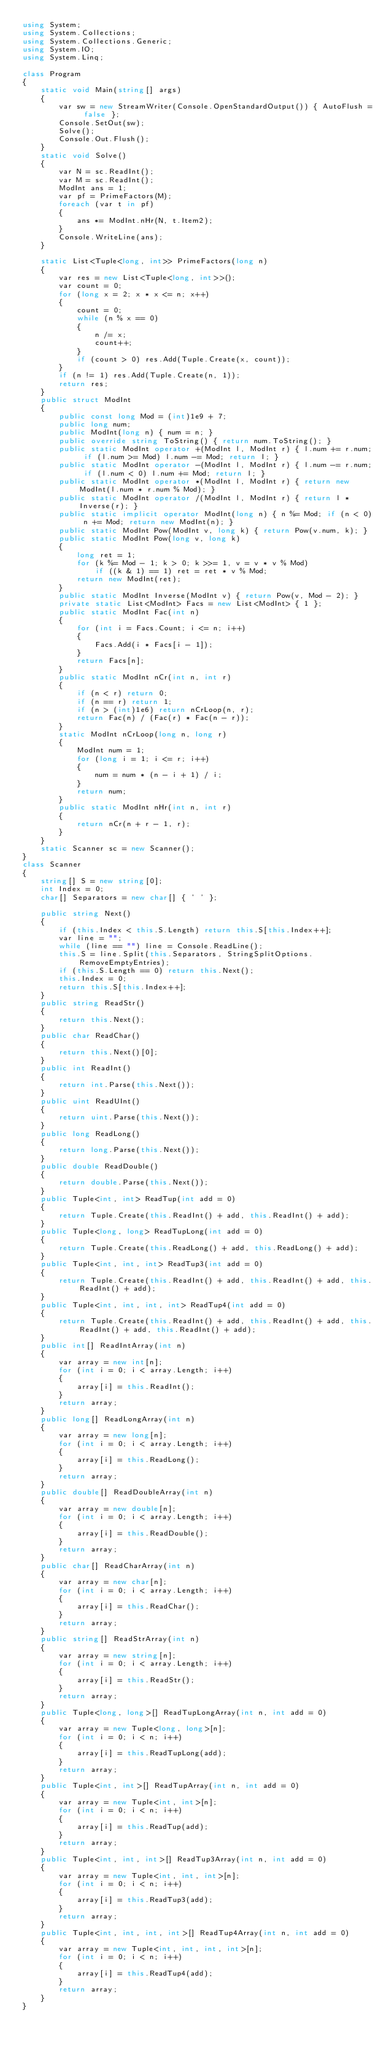<code> <loc_0><loc_0><loc_500><loc_500><_C#_>using System;
using System.Collections;
using System.Collections.Generic;
using System.IO;
using System.Linq;

class Program
{
    static void Main(string[] args)
    {
        var sw = new StreamWriter(Console.OpenStandardOutput()) { AutoFlush = false };
        Console.SetOut(sw);
        Solve();
        Console.Out.Flush();
    }
    static void Solve()
    {
        var N = sc.ReadInt();
        var M = sc.ReadInt();
        ModInt ans = 1;
        var pf = PrimeFactors(M);
        foreach (var t in pf)
        {
            ans *= ModInt.nHr(N, t.Item2);
        }
        Console.WriteLine(ans);
    }

    static List<Tuple<long, int>> PrimeFactors(long n)
    {
        var res = new List<Tuple<long, int>>();
        var count = 0;
        for (long x = 2; x * x <= n; x++)
        {
            count = 0;
            while (n % x == 0)
            {
                n /= x;
                count++;
            }
            if (count > 0) res.Add(Tuple.Create(x, count));
        }
        if (n != 1) res.Add(Tuple.Create(n, 1));
        return res;
    }
    public struct ModInt
    {
        public const long Mod = (int)1e9 + 7;
        public long num;
        public ModInt(long n) { num = n; }
        public override string ToString() { return num.ToString(); }
        public static ModInt operator +(ModInt l, ModInt r) { l.num += r.num; if (l.num >= Mod) l.num -= Mod; return l; }
        public static ModInt operator -(ModInt l, ModInt r) { l.num -= r.num; if (l.num < 0) l.num += Mod; return l; }
        public static ModInt operator *(ModInt l, ModInt r) { return new ModInt(l.num * r.num % Mod); }
        public static ModInt operator /(ModInt l, ModInt r) { return l * Inverse(r); }
        public static implicit operator ModInt(long n) { n %= Mod; if (n < 0) n += Mod; return new ModInt(n); }
        public static ModInt Pow(ModInt v, long k) { return Pow(v.num, k); }
        public static ModInt Pow(long v, long k)
        {
            long ret = 1;
            for (k %= Mod - 1; k > 0; k >>= 1, v = v * v % Mod)
                if ((k & 1) == 1) ret = ret * v % Mod;
            return new ModInt(ret);
        }
        public static ModInt Inverse(ModInt v) { return Pow(v, Mod - 2); }
        private static List<ModInt> Facs = new List<ModInt> { 1 };
        public static ModInt Fac(int n)
        {
            for (int i = Facs.Count; i <= n; i++)
            {
                Facs.Add(i * Facs[i - 1]);
            }
            return Facs[n];
        }
        public static ModInt nCr(int n, int r)
        {
            if (n < r) return 0;
            if (n == r) return 1;
            if (n > (int)1e6) return nCrLoop(n, r);
            return Fac(n) / (Fac(r) * Fac(n - r));
        }
        static ModInt nCrLoop(long n, long r)
        {
            ModInt num = 1;
            for (long i = 1; i <= r; i++)
            {
                num = num * (n - i + 1) / i;
            }
            return num;
        }
        public static ModInt nHr(int n, int r)
        {
            return nCr(n + r - 1, r);
        }
    }
    static Scanner sc = new Scanner();
}
class Scanner
{
    string[] S = new string[0];
    int Index = 0;
    char[] Separators = new char[] { ' ' };

    public string Next()
    {
        if (this.Index < this.S.Length) return this.S[this.Index++];
        var line = "";
        while (line == "") line = Console.ReadLine();
        this.S = line.Split(this.Separators, StringSplitOptions.RemoveEmptyEntries);
        if (this.S.Length == 0) return this.Next();
        this.Index = 0;
        return this.S[this.Index++];
    }
    public string ReadStr()
    {
        return this.Next();
    }
    public char ReadChar()
    {
        return this.Next()[0];
    }
    public int ReadInt()
    {
        return int.Parse(this.Next());
    }
    public uint ReadUInt()
    {
        return uint.Parse(this.Next());
    }
    public long ReadLong()
    {
        return long.Parse(this.Next());
    }
    public double ReadDouble()
    {
        return double.Parse(this.Next());
    }
    public Tuple<int, int> ReadTup(int add = 0)
    {
        return Tuple.Create(this.ReadInt() + add, this.ReadInt() + add);
    }
    public Tuple<long, long> ReadTupLong(int add = 0)
    {
        return Tuple.Create(this.ReadLong() + add, this.ReadLong() + add);
    }
    public Tuple<int, int, int> ReadTup3(int add = 0)
    {
        return Tuple.Create(this.ReadInt() + add, this.ReadInt() + add, this.ReadInt() + add);
    }
    public Tuple<int, int, int, int> ReadTup4(int add = 0)
    {
        return Tuple.Create(this.ReadInt() + add, this.ReadInt() + add, this.ReadInt() + add, this.ReadInt() + add);
    }
    public int[] ReadIntArray(int n)
    {
        var array = new int[n];
        for (int i = 0; i < array.Length; i++)
        {
            array[i] = this.ReadInt();
        }
        return array;
    }
    public long[] ReadLongArray(int n)
    {
        var array = new long[n];
        for (int i = 0; i < array.Length; i++)
        {
            array[i] = this.ReadLong();
        }
        return array;
    }
    public double[] ReadDoubleArray(int n)
    {
        var array = new double[n];
        for (int i = 0; i < array.Length; i++)
        {
            array[i] = this.ReadDouble();
        }
        return array;
    }
    public char[] ReadCharArray(int n)
    {
        var array = new char[n];
        for (int i = 0; i < array.Length; i++)
        {
            array[i] = this.ReadChar();
        }
        return array;
    }
    public string[] ReadStrArray(int n)
    {
        var array = new string[n];
        for (int i = 0; i < array.Length; i++)
        {
            array[i] = this.ReadStr();
        }
        return array;
    }
    public Tuple<long, long>[] ReadTupLongArray(int n, int add = 0)
    {
        var array = new Tuple<long, long>[n];
        for (int i = 0; i < n; i++)
        {
            array[i] = this.ReadTupLong(add);
        }
        return array;
    }
    public Tuple<int, int>[] ReadTupArray(int n, int add = 0)
    {
        var array = new Tuple<int, int>[n];
        for (int i = 0; i < n; i++)
        {
            array[i] = this.ReadTup(add);
        }
        return array;
    }
    public Tuple<int, int, int>[] ReadTup3Array(int n, int add = 0)
    {
        var array = new Tuple<int, int, int>[n];
        for (int i = 0; i < n; i++)
        {
            array[i] = this.ReadTup3(add);
        }
        return array;
    }
    public Tuple<int, int, int, int>[] ReadTup4Array(int n, int add = 0)
    {
        var array = new Tuple<int, int, int, int>[n];
        for (int i = 0; i < n; i++)
        {
            array[i] = this.ReadTup4(add);
        }
        return array;
    }
}
</code> 